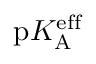Convert formula to latex. <formula><loc_0><loc_0><loc_500><loc_500>p K _ { A } ^ { e f f }</formula> 